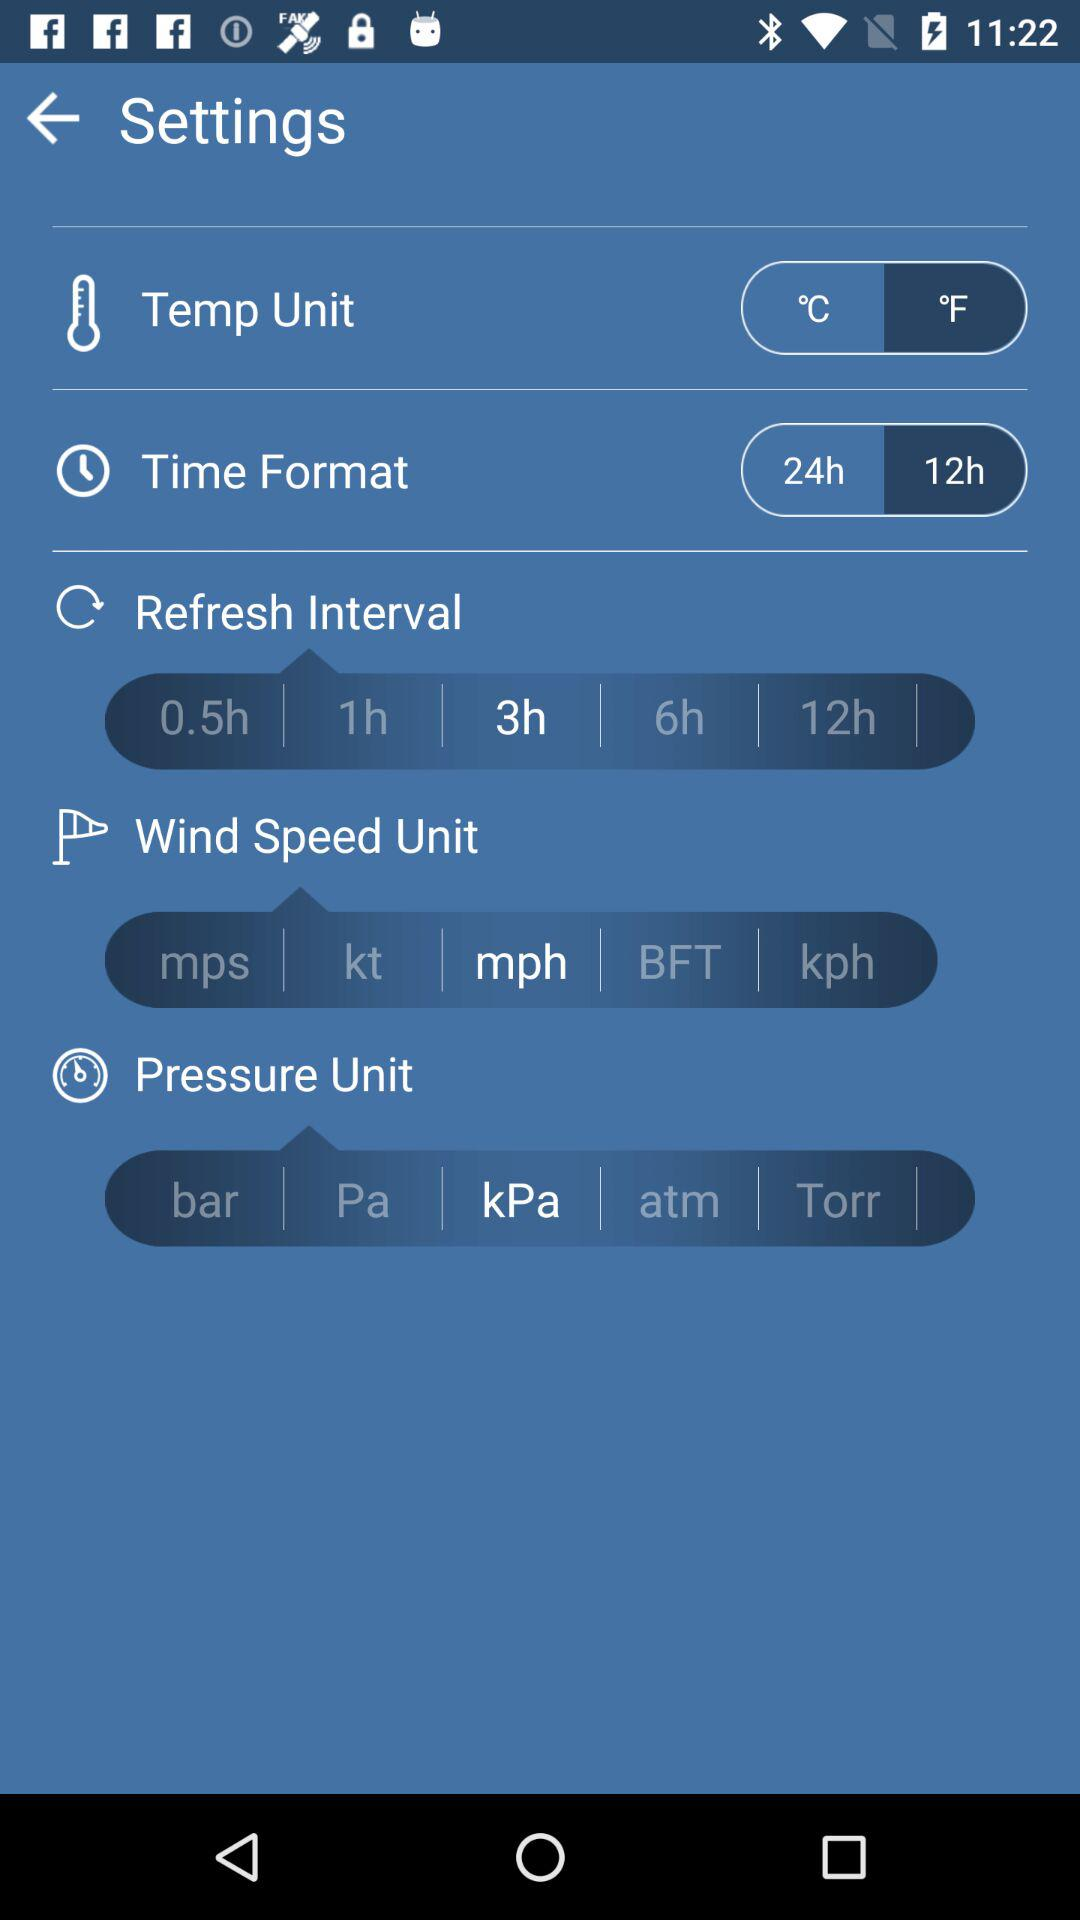What is the selected unit of the wind speed? The selected unit of the wind speed is mph. 